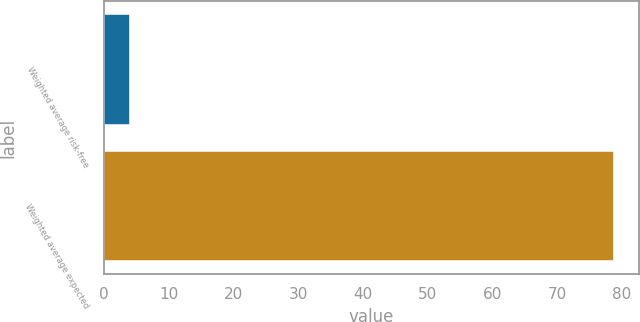Convert chart to OTSL. <chart><loc_0><loc_0><loc_500><loc_500><bar_chart><fcel>Weighted average risk-free<fcel>Weighted average expected<nl><fcel>3.98<fcel>78.7<nl></chart> 